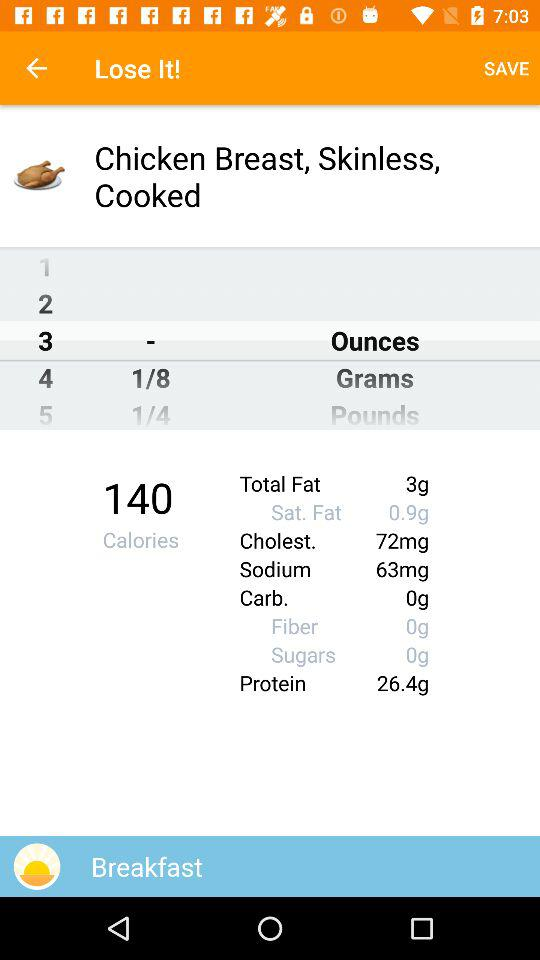What is the amount of cholesterol? The amount of cholesterol is 72 mg. 